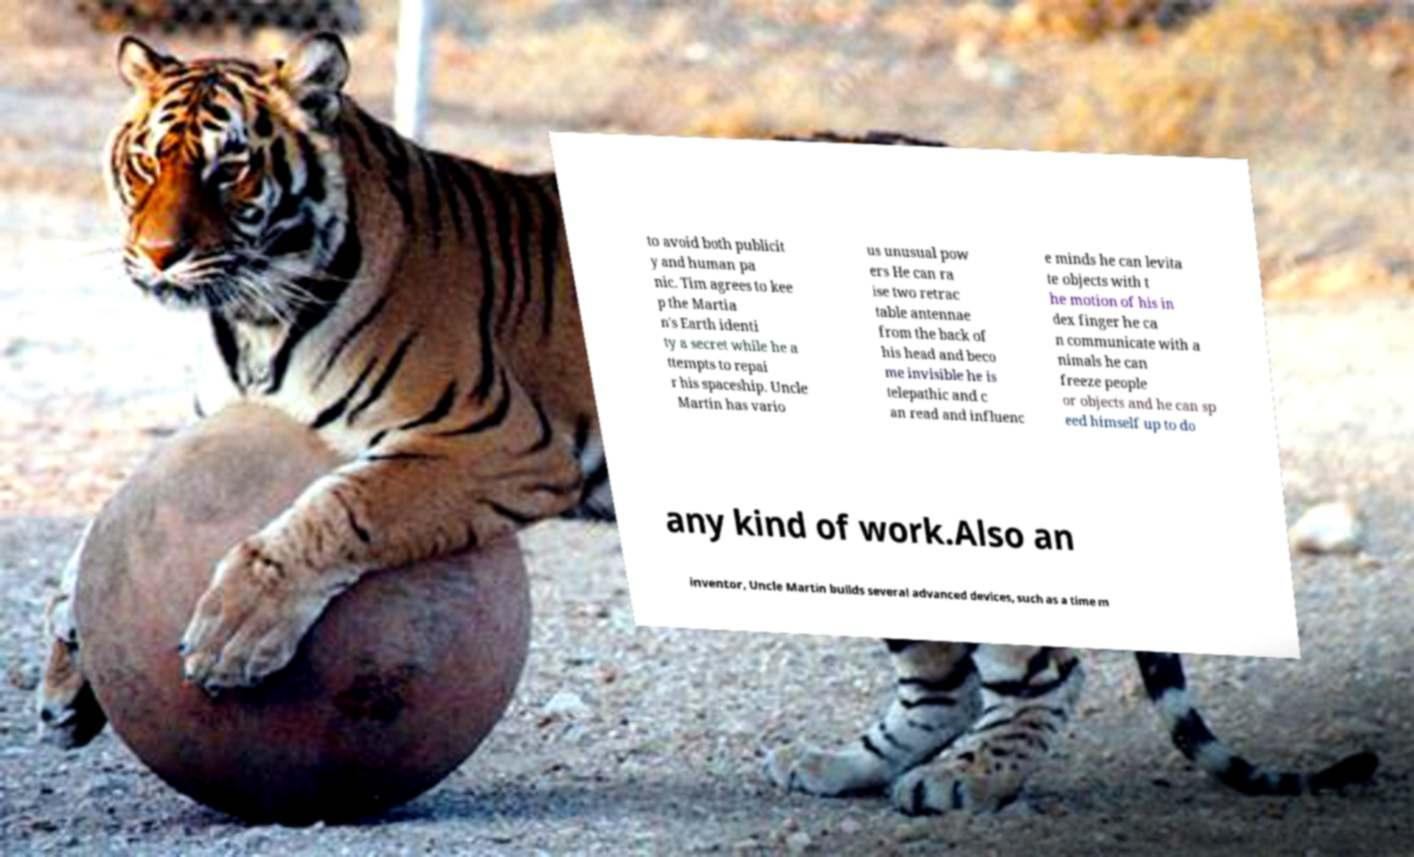Please identify and transcribe the text found in this image. to avoid both publicit y and human pa nic. Tim agrees to kee p the Martia n's Earth identi ty a secret while he a ttempts to repai r his spaceship. Uncle Martin has vario us unusual pow ers He can ra ise two retrac table antennae from the back of his head and beco me invisible he is telepathic and c an read and influenc e minds he can levita te objects with t he motion of his in dex finger he ca n communicate with a nimals he can freeze people or objects and he can sp eed himself up to do any kind of work.Also an inventor, Uncle Martin builds several advanced devices, such as a time m 